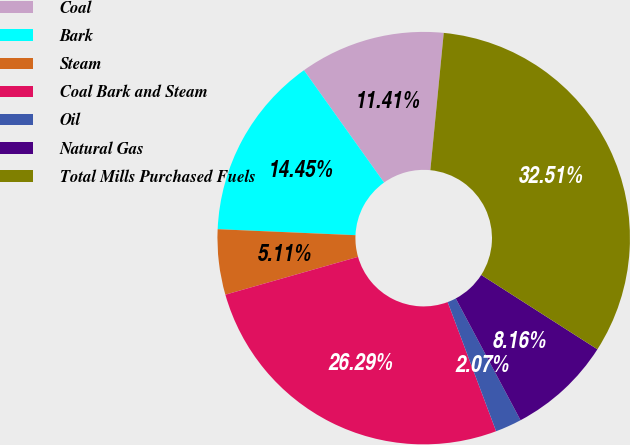<chart> <loc_0><loc_0><loc_500><loc_500><pie_chart><fcel>Coal<fcel>Bark<fcel>Steam<fcel>Coal Bark and Steam<fcel>Oil<fcel>Natural Gas<fcel>Total Mills Purchased Fuels<nl><fcel>11.41%<fcel>14.45%<fcel>5.11%<fcel>26.29%<fcel>2.07%<fcel>8.16%<fcel>32.51%<nl></chart> 